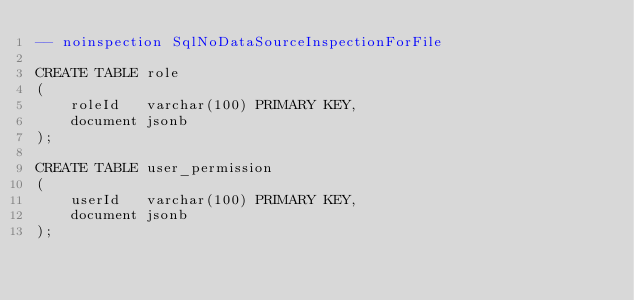<code> <loc_0><loc_0><loc_500><loc_500><_SQL_>-- noinspection SqlNoDataSourceInspectionForFile

CREATE TABLE role
(
    roleId   varchar(100) PRIMARY KEY,
    document jsonb
);

CREATE TABLE user_permission
(
    userId   varchar(100) PRIMARY KEY,
    document jsonb
);
</code> 